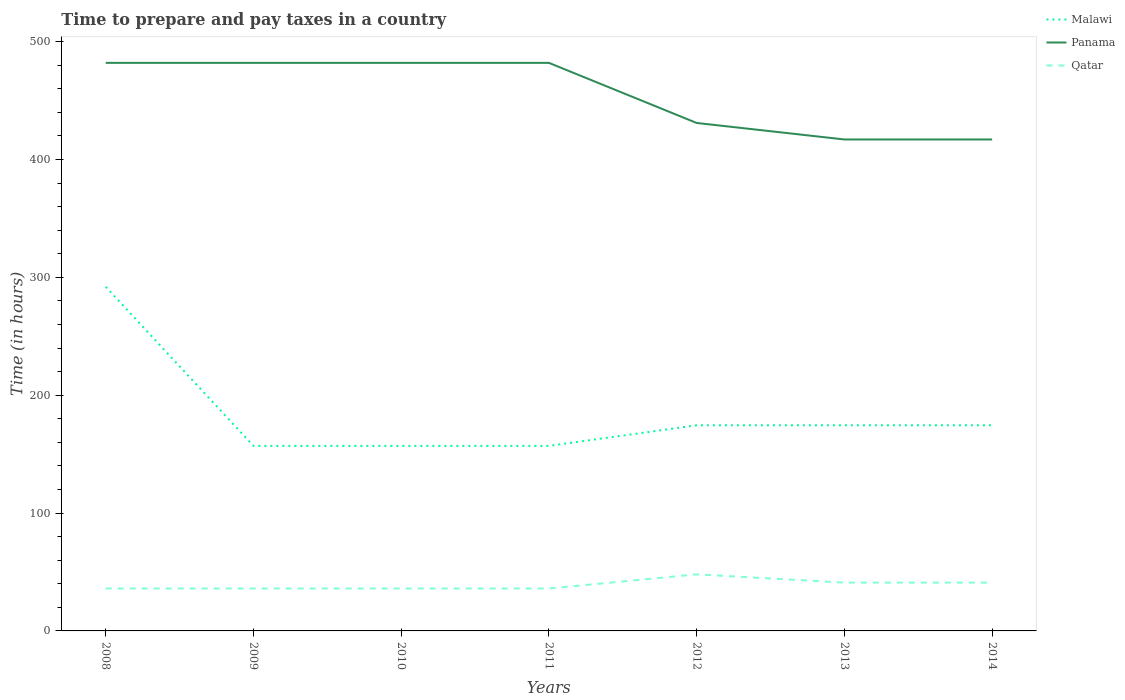How many different coloured lines are there?
Provide a succinct answer. 3. Does the line corresponding to Malawi intersect with the line corresponding to Panama?
Your answer should be very brief. No. Is the number of lines equal to the number of legend labels?
Keep it short and to the point. Yes. Across all years, what is the maximum number of hours required to prepare and pay taxes in Malawi?
Provide a short and direct response. 157. In which year was the number of hours required to prepare and pay taxes in Qatar maximum?
Provide a succinct answer. 2008. What is the total number of hours required to prepare and pay taxes in Panama in the graph?
Offer a terse response. 65. What is the difference between the highest and the second highest number of hours required to prepare and pay taxes in Malawi?
Give a very brief answer. 135. Is the number of hours required to prepare and pay taxes in Panama strictly greater than the number of hours required to prepare and pay taxes in Qatar over the years?
Make the answer very short. No. How many lines are there?
Your answer should be very brief. 3. What is the difference between two consecutive major ticks on the Y-axis?
Your answer should be compact. 100. Does the graph contain any zero values?
Your response must be concise. No. Where does the legend appear in the graph?
Ensure brevity in your answer.  Top right. How many legend labels are there?
Offer a very short reply. 3. How are the legend labels stacked?
Keep it short and to the point. Vertical. What is the title of the graph?
Your response must be concise. Time to prepare and pay taxes in a country. What is the label or title of the X-axis?
Your answer should be very brief. Years. What is the label or title of the Y-axis?
Ensure brevity in your answer.  Time (in hours). What is the Time (in hours) of Malawi in 2008?
Your answer should be compact. 292. What is the Time (in hours) of Panama in 2008?
Keep it short and to the point. 482. What is the Time (in hours) of Malawi in 2009?
Provide a short and direct response. 157. What is the Time (in hours) of Panama in 2009?
Make the answer very short. 482. What is the Time (in hours) in Malawi in 2010?
Your response must be concise. 157. What is the Time (in hours) of Panama in 2010?
Your response must be concise. 482. What is the Time (in hours) of Malawi in 2011?
Make the answer very short. 157. What is the Time (in hours) in Panama in 2011?
Your answer should be compact. 482. What is the Time (in hours) of Qatar in 2011?
Your answer should be compact. 36. What is the Time (in hours) in Malawi in 2012?
Provide a succinct answer. 174.5. What is the Time (in hours) of Panama in 2012?
Your answer should be very brief. 431. What is the Time (in hours) in Qatar in 2012?
Provide a succinct answer. 48. What is the Time (in hours) of Malawi in 2013?
Your answer should be very brief. 174.5. What is the Time (in hours) of Panama in 2013?
Ensure brevity in your answer.  417. What is the Time (in hours) of Malawi in 2014?
Your response must be concise. 174.5. What is the Time (in hours) in Panama in 2014?
Give a very brief answer. 417. What is the Time (in hours) in Qatar in 2014?
Keep it short and to the point. 41. Across all years, what is the maximum Time (in hours) of Malawi?
Your answer should be compact. 292. Across all years, what is the maximum Time (in hours) in Panama?
Offer a terse response. 482. Across all years, what is the minimum Time (in hours) in Malawi?
Your answer should be very brief. 157. Across all years, what is the minimum Time (in hours) of Panama?
Offer a terse response. 417. What is the total Time (in hours) in Malawi in the graph?
Your response must be concise. 1286.5. What is the total Time (in hours) of Panama in the graph?
Provide a short and direct response. 3193. What is the total Time (in hours) in Qatar in the graph?
Keep it short and to the point. 274. What is the difference between the Time (in hours) in Malawi in 2008 and that in 2009?
Provide a succinct answer. 135. What is the difference between the Time (in hours) in Panama in 2008 and that in 2009?
Your response must be concise. 0. What is the difference between the Time (in hours) in Malawi in 2008 and that in 2010?
Your answer should be compact. 135. What is the difference between the Time (in hours) in Qatar in 2008 and that in 2010?
Provide a short and direct response. 0. What is the difference between the Time (in hours) in Malawi in 2008 and that in 2011?
Ensure brevity in your answer.  135. What is the difference between the Time (in hours) of Malawi in 2008 and that in 2012?
Your response must be concise. 117.5. What is the difference between the Time (in hours) of Panama in 2008 and that in 2012?
Offer a terse response. 51. What is the difference between the Time (in hours) in Qatar in 2008 and that in 2012?
Provide a succinct answer. -12. What is the difference between the Time (in hours) of Malawi in 2008 and that in 2013?
Make the answer very short. 117.5. What is the difference between the Time (in hours) of Qatar in 2008 and that in 2013?
Provide a short and direct response. -5. What is the difference between the Time (in hours) in Malawi in 2008 and that in 2014?
Your answer should be compact. 117.5. What is the difference between the Time (in hours) in Panama in 2008 and that in 2014?
Your response must be concise. 65. What is the difference between the Time (in hours) in Malawi in 2009 and that in 2010?
Keep it short and to the point. 0. What is the difference between the Time (in hours) in Malawi in 2009 and that in 2011?
Provide a succinct answer. 0. What is the difference between the Time (in hours) in Qatar in 2009 and that in 2011?
Provide a succinct answer. 0. What is the difference between the Time (in hours) of Malawi in 2009 and that in 2012?
Give a very brief answer. -17.5. What is the difference between the Time (in hours) in Panama in 2009 and that in 2012?
Provide a succinct answer. 51. What is the difference between the Time (in hours) in Malawi in 2009 and that in 2013?
Offer a terse response. -17.5. What is the difference between the Time (in hours) of Qatar in 2009 and that in 2013?
Your response must be concise. -5. What is the difference between the Time (in hours) of Malawi in 2009 and that in 2014?
Keep it short and to the point. -17.5. What is the difference between the Time (in hours) in Panama in 2009 and that in 2014?
Provide a short and direct response. 65. What is the difference between the Time (in hours) of Malawi in 2010 and that in 2011?
Offer a terse response. 0. What is the difference between the Time (in hours) in Panama in 2010 and that in 2011?
Keep it short and to the point. 0. What is the difference between the Time (in hours) of Malawi in 2010 and that in 2012?
Provide a succinct answer. -17.5. What is the difference between the Time (in hours) of Malawi in 2010 and that in 2013?
Your answer should be compact. -17.5. What is the difference between the Time (in hours) in Malawi in 2010 and that in 2014?
Give a very brief answer. -17.5. What is the difference between the Time (in hours) of Panama in 2010 and that in 2014?
Your response must be concise. 65. What is the difference between the Time (in hours) of Qatar in 2010 and that in 2014?
Offer a terse response. -5. What is the difference between the Time (in hours) in Malawi in 2011 and that in 2012?
Offer a terse response. -17.5. What is the difference between the Time (in hours) in Panama in 2011 and that in 2012?
Your answer should be very brief. 51. What is the difference between the Time (in hours) in Qatar in 2011 and that in 2012?
Your response must be concise. -12. What is the difference between the Time (in hours) of Malawi in 2011 and that in 2013?
Offer a terse response. -17.5. What is the difference between the Time (in hours) of Qatar in 2011 and that in 2013?
Give a very brief answer. -5. What is the difference between the Time (in hours) in Malawi in 2011 and that in 2014?
Provide a short and direct response. -17.5. What is the difference between the Time (in hours) in Qatar in 2011 and that in 2014?
Offer a very short reply. -5. What is the difference between the Time (in hours) of Panama in 2012 and that in 2013?
Provide a succinct answer. 14. What is the difference between the Time (in hours) of Qatar in 2012 and that in 2013?
Keep it short and to the point. 7. What is the difference between the Time (in hours) in Malawi in 2012 and that in 2014?
Your answer should be compact. 0. What is the difference between the Time (in hours) in Panama in 2012 and that in 2014?
Give a very brief answer. 14. What is the difference between the Time (in hours) in Qatar in 2013 and that in 2014?
Ensure brevity in your answer.  0. What is the difference between the Time (in hours) of Malawi in 2008 and the Time (in hours) of Panama in 2009?
Make the answer very short. -190. What is the difference between the Time (in hours) of Malawi in 2008 and the Time (in hours) of Qatar in 2009?
Keep it short and to the point. 256. What is the difference between the Time (in hours) of Panama in 2008 and the Time (in hours) of Qatar in 2009?
Make the answer very short. 446. What is the difference between the Time (in hours) of Malawi in 2008 and the Time (in hours) of Panama in 2010?
Your response must be concise. -190. What is the difference between the Time (in hours) in Malawi in 2008 and the Time (in hours) in Qatar in 2010?
Offer a terse response. 256. What is the difference between the Time (in hours) in Panama in 2008 and the Time (in hours) in Qatar in 2010?
Offer a terse response. 446. What is the difference between the Time (in hours) of Malawi in 2008 and the Time (in hours) of Panama in 2011?
Your answer should be very brief. -190. What is the difference between the Time (in hours) in Malawi in 2008 and the Time (in hours) in Qatar in 2011?
Make the answer very short. 256. What is the difference between the Time (in hours) in Panama in 2008 and the Time (in hours) in Qatar in 2011?
Provide a succinct answer. 446. What is the difference between the Time (in hours) of Malawi in 2008 and the Time (in hours) of Panama in 2012?
Give a very brief answer. -139. What is the difference between the Time (in hours) in Malawi in 2008 and the Time (in hours) in Qatar in 2012?
Offer a very short reply. 244. What is the difference between the Time (in hours) in Panama in 2008 and the Time (in hours) in Qatar in 2012?
Keep it short and to the point. 434. What is the difference between the Time (in hours) of Malawi in 2008 and the Time (in hours) of Panama in 2013?
Your answer should be compact. -125. What is the difference between the Time (in hours) of Malawi in 2008 and the Time (in hours) of Qatar in 2013?
Provide a succinct answer. 251. What is the difference between the Time (in hours) in Panama in 2008 and the Time (in hours) in Qatar in 2013?
Provide a succinct answer. 441. What is the difference between the Time (in hours) of Malawi in 2008 and the Time (in hours) of Panama in 2014?
Provide a succinct answer. -125. What is the difference between the Time (in hours) of Malawi in 2008 and the Time (in hours) of Qatar in 2014?
Your answer should be very brief. 251. What is the difference between the Time (in hours) in Panama in 2008 and the Time (in hours) in Qatar in 2014?
Ensure brevity in your answer.  441. What is the difference between the Time (in hours) in Malawi in 2009 and the Time (in hours) in Panama in 2010?
Offer a very short reply. -325. What is the difference between the Time (in hours) in Malawi in 2009 and the Time (in hours) in Qatar in 2010?
Give a very brief answer. 121. What is the difference between the Time (in hours) in Panama in 2009 and the Time (in hours) in Qatar in 2010?
Your answer should be very brief. 446. What is the difference between the Time (in hours) in Malawi in 2009 and the Time (in hours) in Panama in 2011?
Provide a succinct answer. -325. What is the difference between the Time (in hours) of Malawi in 2009 and the Time (in hours) of Qatar in 2011?
Keep it short and to the point. 121. What is the difference between the Time (in hours) in Panama in 2009 and the Time (in hours) in Qatar in 2011?
Your answer should be compact. 446. What is the difference between the Time (in hours) in Malawi in 2009 and the Time (in hours) in Panama in 2012?
Provide a succinct answer. -274. What is the difference between the Time (in hours) in Malawi in 2009 and the Time (in hours) in Qatar in 2012?
Offer a terse response. 109. What is the difference between the Time (in hours) in Panama in 2009 and the Time (in hours) in Qatar in 2012?
Your answer should be very brief. 434. What is the difference between the Time (in hours) of Malawi in 2009 and the Time (in hours) of Panama in 2013?
Ensure brevity in your answer.  -260. What is the difference between the Time (in hours) in Malawi in 2009 and the Time (in hours) in Qatar in 2013?
Make the answer very short. 116. What is the difference between the Time (in hours) in Panama in 2009 and the Time (in hours) in Qatar in 2013?
Offer a very short reply. 441. What is the difference between the Time (in hours) in Malawi in 2009 and the Time (in hours) in Panama in 2014?
Your answer should be compact. -260. What is the difference between the Time (in hours) in Malawi in 2009 and the Time (in hours) in Qatar in 2014?
Your answer should be very brief. 116. What is the difference between the Time (in hours) in Panama in 2009 and the Time (in hours) in Qatar in 2014?
Your answer should be compact. 441. What is the difference between the Time (in hours) of Malawi in 2010 and the Time (in hours) of Panama in 2011?
Give a very brief answer. -325. What is the difference between the Time (in hours) in Malawi in 2010 and the Time (in hours) in Qatar in 2011?
Ensure brevity in your answer.  121. What is the difference between the Time (in hours) in Panama in 2010 and the Time (in hours) in Qatar in 2011?
Provide a short and direct response. 446. What is the difference between the Time (in hours) of Malawi in 2010 and the Time (in hours) of Panama in 2012?
Your response must be concise. -274. What is the difference between the Time (in hours) in Malawi in 2010 and the Time (in hours) in Qatar in 2012?
Give a very brief answer. 109. What is the difference between the Time (in hours) of Panama in 2010 and the Time (in hours) of Qatar in 2012?
Your answer should be very brief. 434. What is the difference between the Time (in hours) in Malawi in 2010 and the Time (in hours) in Panama in 2013?
Give a very brief answer. -260. What is the difference between the Time (in hours) in Malawi in 2010 and the Time (in hours) in Qatar in 2013?
Your response must be concise. 116. What is the difference between the Time (in hours) of Panama in 2010 and the Time (in hours) of Qatar in 2013?
Keep it short and to the point. 441. What is the difference between the Time (in hours) in Malawi in 2010 and the Time (in hours) in Panama in 2014?
Keep it short and to the point. -260. What is the difference between the Time (in hours) of Malawi in 2010 and the Time (in hours) of Qatar in 2014?
Keep it short and to the point. 116. What is the difference between the Time (in hours) in Panama in 2010 and the Time (in hours) in Qatar in 2014?
Your answer should be very brief. 441. What is the difference between the Time (in hours) in Malawi in 2011 and the Time (in hours) in Panama in 2012?
Provide a succinct answer. -274. What is the difference between the Time (in hours) of Malawi in 2011 and the Time (in hours) of Qatar in 2012?
Offer a very short reply. 109. What is the difference between the Time (in hours) of Panama in 2011 and the Time (in hours) of Qatar in 2012?
Ensure brevity in your answer.  434. What is the difference between the Time (in hours) in Malawi in 2011 and the Time (in hours) in Panama in 2013?
Keep it short and to the point. -260. What is the difference between the Time (in hours) in Malawi in 2011 and the Time (in hours) in Qatar in 2013?
Offer a terse response. 116. What is the difference between the Time (in hours) of Panama in 2011 and the Time (in hours) of Qatar in 2013?
Offer a very short reply. 441. What is the difference between the Time (in hours) of Malawi in 2011 and the Time (in hours) of Panama in 2014?
Offer a very short reply. -260. What is the difference between the Time (in hours) in Malawi in 2011 and the Time (in hours) in Qatar in 2014?
Ensure brevity in your answer.  116. What is the difference between the Time (in hours) in Panama in 2011 and the Time (in hours) in Qatar in 2014?
Give a very brief answer. 441. What is the difference between the Time (in hours) of Malawi in 2012 and the Time (in hours) of Panama in 2013?
Make the answer very short. -242.5. What is the difference between the Time (in hours) of Malawi in 2012 and the Time (in hours) of Qatar in 2013?
Keep it short and to the point. 133.5. What is the difference between the Time (in hours) of Panama in 2012 and the Time (in hours) of Qatar in 2013?
Make the answer very short. 390. What is the difference between the Time (in hours) of Malawi in 2012 and the Time (in hours) of Panama in 2014?
Your response must be concise. -242.5. What is the difference between the Time (in hours) of Malawi in 2012 and the Time (in hours) of Qatar in 2014?
Keep it short and to the point. 133.5. What is the difference between the Time (in hours) of Panama in 2012 and the Time (in hours) of Qatar in 2014?
Your answer should be compact. 390. What is the difference between the Time (in hours) in Malawi in 2013 and the Time (in hours) in Panama in 2014?
Keep it short and to the point. -242.5. What is the difference between the Time (in hours) in Malawi in 2013 and the Time (in hours) in Qatar in 2014?
Make the answer very short. 133.5. What is the difference between the Time (in hours) of Panama in 2013 and the Time (in hours) of Qatar in 2014?
Provide a short and direct response. 376. What is the average Time (in hours) in Malawi per year?
Give a very brief answer. 183.79. What is the average Time (in hours) of Panama per year?
Your answer should be compact. 456.14. What is the average Time (in hours) in Qatar per year?
Your answer should be compact. 39.14. In the year 2008, what is the difference between the Time (in hours) of Malawi and Time (in hours) of Panama?
Ensure brevity in your answer.  -190. In the year 2008, what is the difference between the Time (in hours) of Malawi and Time (in hours) of Qatar?
Give a very brief answer. 256. In the year 2008, what is the difference between the Time (in hours) of Panama and Time (in hours) of Qatar?
Keep it short and to the point. 446. In the year 2009, what is the difference between the Time (in hours) of Malawi and Time (in hours) of Panama?
Your answer should be compact. -325. In the year 2009, what is the difference between the Time (in hours) of Malawi and Time (in hours) of Qatar?
Provide a short and direct response. 121. In the year 2009, what is the difference between the Time (in hours) in Panama and Time (in hours) in Qatar?
Ensure brevity in your answer.  446. In the year 2010, what is the difference between the Time (in hours) of Malawi and Time (in hours) of Panama?
Provide a short and direct response. -325. In the year 2010, what is the difference between the Time (in hours) in Malawi and Time (in hours) in Qatar?
Your answer should be very brief. 121. In the year 2010, what is the difference between the Time (in hours) of Panama and Time (in hours) of Qatar?
Your response must be concise. 446. In the year 2011, what is the difference between the Time (in hours) of Malawi and Time (in hours) of Panama?
Offer a terse response. -325. In the year 2011, what is the difference between the Time (in hours) of Malawi and Time (in hours) of Qatar?
Provide a short and direct response. 121. In the year 2011, what is the difference between the Time (in hours) of Panama and Time (in hours) of Qatar?
Keep it short and to the point. 446. In the year 2012, what is the difference between the Time (in hours) of Malawi and Time (in hours) of Panama?
Make the answer very short. -256.5. In the year 2012, what is the difference between the Time (in hours) in Malawi and Time (in hours) in Qatar?
Provide a short and direct response. 126.5. In the year 2012, what is the difference between the Time (in hours) in Panama and Time (in hours) in Qatar?
Your answer should be very brief. 383. In the year 2013, what is the difference between the Time (in hours) of Malawi and Time (in hours) of Panama?
Offer a terse response. -242.5. In the year 2013, what is the difference between the Time (in hours) of Malawi and Time (in hours) of Qatar?
Your answer should be very brief. 133.5. In the year 2013, what is the difference between the Time (in hours) of Panama and Time (in hours) of Qatar?
Ensure brevity in your answer.  376. In the year 2014, what is the difference between the Time (in hours) in Malawi and Time (in hours) in Panama?
Your answer should be very brief. -242.5. In the year 2014, what is the difference between the Time (in hours) in Malawi and Time (in hours) in Qatar?
Provide a short and direct response. 133.5. In the year 2014, what is the difference between the Time (in hours) of Panama and Time (in hours) of Qatar?
Your answer should be very brief. 376. What is the ratio of the Time (in hours) of Malawi in 2008 to that in 2009?
Provide a short and direct response. 1.86. What is the ratio of the Time (in hours) of Malawi in 2008 to that in 2010?
Your answer should be compact. 1.86. What is the ratio of the Time (in hours) in Panama in 2008 to that in 2010?
Your answer should be compact. 1. What is the ratio of the Time (in hours) in Qatar in 2008 to that in 2010?
Provide a short and direct response. 1. What is the ratio of the Time (in hours) in Malawi in 2008 to that in 2011?
Offer a very short reply. 1.86. What is the ratio of the Time (in hours) of Qatar in 2008 to that in 2011?
Keep it short and to the point. 1. What is the ratio of the Time (in hours) of Malawi in 2008 to that in 2012?
Your response must be concise. 1.67. What is the ratio of the Time (in hours) in Panama in 2008 to that in 2012?
Offer a terse response. 1.12. What is the ratio of the Time (in hours) in Qatar in 2008 to that in 2012?
Ensure brevity in your answer.  0.75. What is the ratio of the Time (in hours) of Malawi in 2008 to that in 2013?
Provide a short and direct response. 1.67. What is the ratio of the Time (in hours) of Panama in 2008 to that in 2013?
Offer a terse response. 1.16. What is the ratio of the Time (in hours) of Qatar in 2008 to that in 2013?
Provide a succinct answer. 0.88. What is the ratio of the Time (in hours) of Malawi in 2008 to that in 2014?
Offer a terse response. 1.67. What is the ratio of the Time (in hours) of Panama in 2008 to that in 2014?
Make the answer very short. 1.16. What is the ratio of the Time (in hours) in Qatar in 2008 to that in 2014?
Your answer should be compact. 0.88. What is the ratio of the Time (in hours) in Malawi in 2009 to that in 2010?
Offer a very short reply. 1. What is the ratio of the Time (in hours) in Panama in 2009 to that in 2010?
Your answer should be compact. 1. What is the ratio of the Time (in hours) in Qatar in 2009 to that in 2010?
Ensure brevity in your answer.  1. What is the ratio of the Time (in hours) of Panama in 2009 to that in 2011?
Offer a very short reply. 1. What is the ratio of the Time (in hours) of Malawi in 2009 to that in 2012?
Your response must be concise. 0.9. What is the ratio of the Time (in hours) in Panama in 2009 to that in 2012?
Provide a succinct answer. 1.12. What is the ratio of the Time (in hours) of Qatar in 2009 to that in 2012?
Offer a terse response. 0.75. What is the ratio of the Time (in hours) of Malawi in 2009 to that in 2013?
Offer a terse response. 0.9. What is the ratio of the Time (in hours) of Panama in 2009 to that in 2013?
Your answer should be compact. 1.16. What is the ratio of the Time (in hours) of Qatar in 2009 to that in 2013?
Give a very brief answer. 0.88. What is the ratio of the Time (in hours) of Malawi in 2009 to that in 2014?
Ensure brevity in your answer.  0.9. What is the ratio of the Time (in hours) in Panama in 2009 to that in 2014?
Offer a terse response. 1.16. What is the ratio of the Time (in hours) of Qatar in 2009 to that in 2014?
Offer a terse response. 0.88. What is the ratio of the Time (in hours) of Malawi in 2010 to that in 2011?
Provide a succinct answer. 1. What is the ratio of the Time (in hours) in Panama in 2010 to that in 2011?
Provide a short and direct response. 1. What is the ratio of the Time (in hours) of Malawi in 2010 to that in 2012?
Your answer should be compact. 0.9. What is the ratio of the Time (in hours) in Panama in 2010 to that in 2012?
Make the answer very short. 1.12. What is the ratio of the Time (in hours) in Malawi in 2010 to that in 2013?
Give a very brief answer. 0.9. What is the ratio of the Time (in hours) of Panama in 2010 to that in 2013?
Offer a very short reply. 1.16. What is the ratio of the Time (in hours) in Qatar in 2010 to that in 2013?
Keep it short and to the point. 0.88. What is the ratio of the Time (in hours) in Malawi in 2010 to that in 2014?
Offer a terse response. 0.9. What is the ratio of the Time (in hours) in Panama in 2010 to that in 2014?
Give a very brief answer. 1.16. What is the ratio of the Time (in hours) of Qatar in 2010 to that in 2014?
Your answer should be compact. 0.88. What is the ratio of the Time (in hours) in Malawi in 2011 to that in 2012?
Provide a succinct answer. 0.9. What is the ratio of the Time (in hours) of Panama in 2011 to that in 2012?
Offer a very short reply. 1.12. What is the ratio of the Time (in hours) of Qatar in 2011 to that in 2012?
Ensure brevity in your answer.  0.75. What is the ratio of the Time (in hours) of Malawi in 2011 to that in 2013?
Give a very brief answer. 0.9. What is the ratio of the Time (in hours) of Panama in 2011 to that in 2013?
Give a very brief answer. 1.16. What is the ratio of the Time (in hours) in Qatar in 2011 to that in 2013?
Provide a succinct answer. 0.88. What is the ratio of the Time (in hours) of Malawi in 2011 to that in 2014?
Keep it short and to the point. 0.9. What is the ratio of the Time (in hours) in Panama in 2011 to that in 2014?
Provide a short and direct response. 1.16. What is the ratio of the Time (in hours) of Qatar in 2011 to that in 2014?
Make the answer very short. 0.88. What is the ratio of the Time (in hours) of Malawi in 2012 to that in 2013?
Your answer should be very brief. 1. What is the ratio of the Time (in hours) in Panama in 2012 to that in 2013?
Your answer should be very brief. 1.03. What is the ratio of the Time (in hours) of Qatar in 2012 to that in 2013?
Make the answer very short. 1.17. What is the ratio of the Time (in hours) in Panama in 2012 to that in 2014?
Ensure brevity in your answer.  1.03. What is the ratio of the Time (in hours) of Qatar in 2012 to that in 2014?
Offer a very short reply. 1.17. What is the difference between the highest and the second highest Time (in hours) of Malawi?
Ensure brevity in your answer.  117.5. What is the difference between the highest and the lowest Time (in hours) of Malawi?
Keep it short and to the point. 135. What is the difference between the highest and the lowest Time (in hours) of Panama?
Your answer should be compact. 65. What is the difference between the highest and the lowest Time (in hours) in Qatar?
Your response must be concise. 12. 